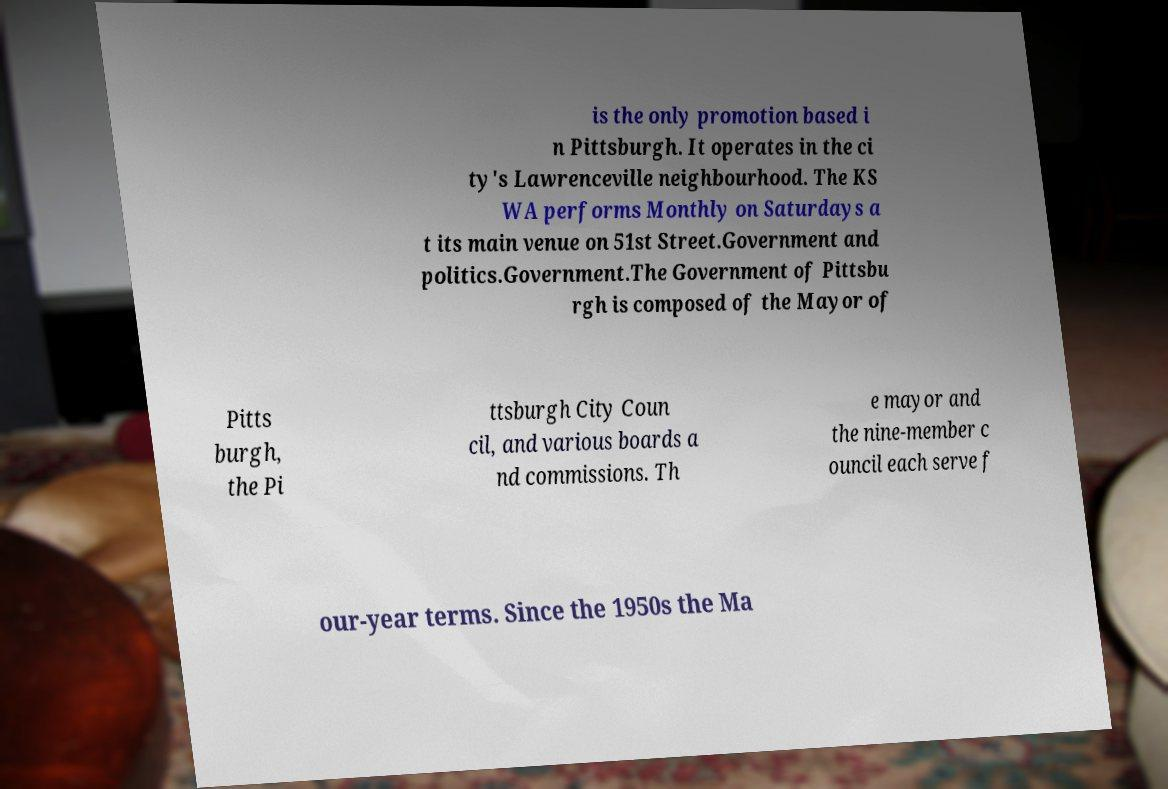I need the written content from this picture converted into text. Can you do that? is the only promotion based i n Pittsburgh. It operates in the ci ty's Lawrenceville neighbourhood. The KS WA performs Monthly on Saturdays a t its main venue on 51st Street.Government and politics.Government.The Government of Pittsbu rgh is composed of the Mayor of Pitts burgh, the Pi ttsburgh City Coun cil, and various boards a nd commissions. Th e mayor and the nine-member c ouncil each serve f our-year terms. Since the 1950s the Ma 